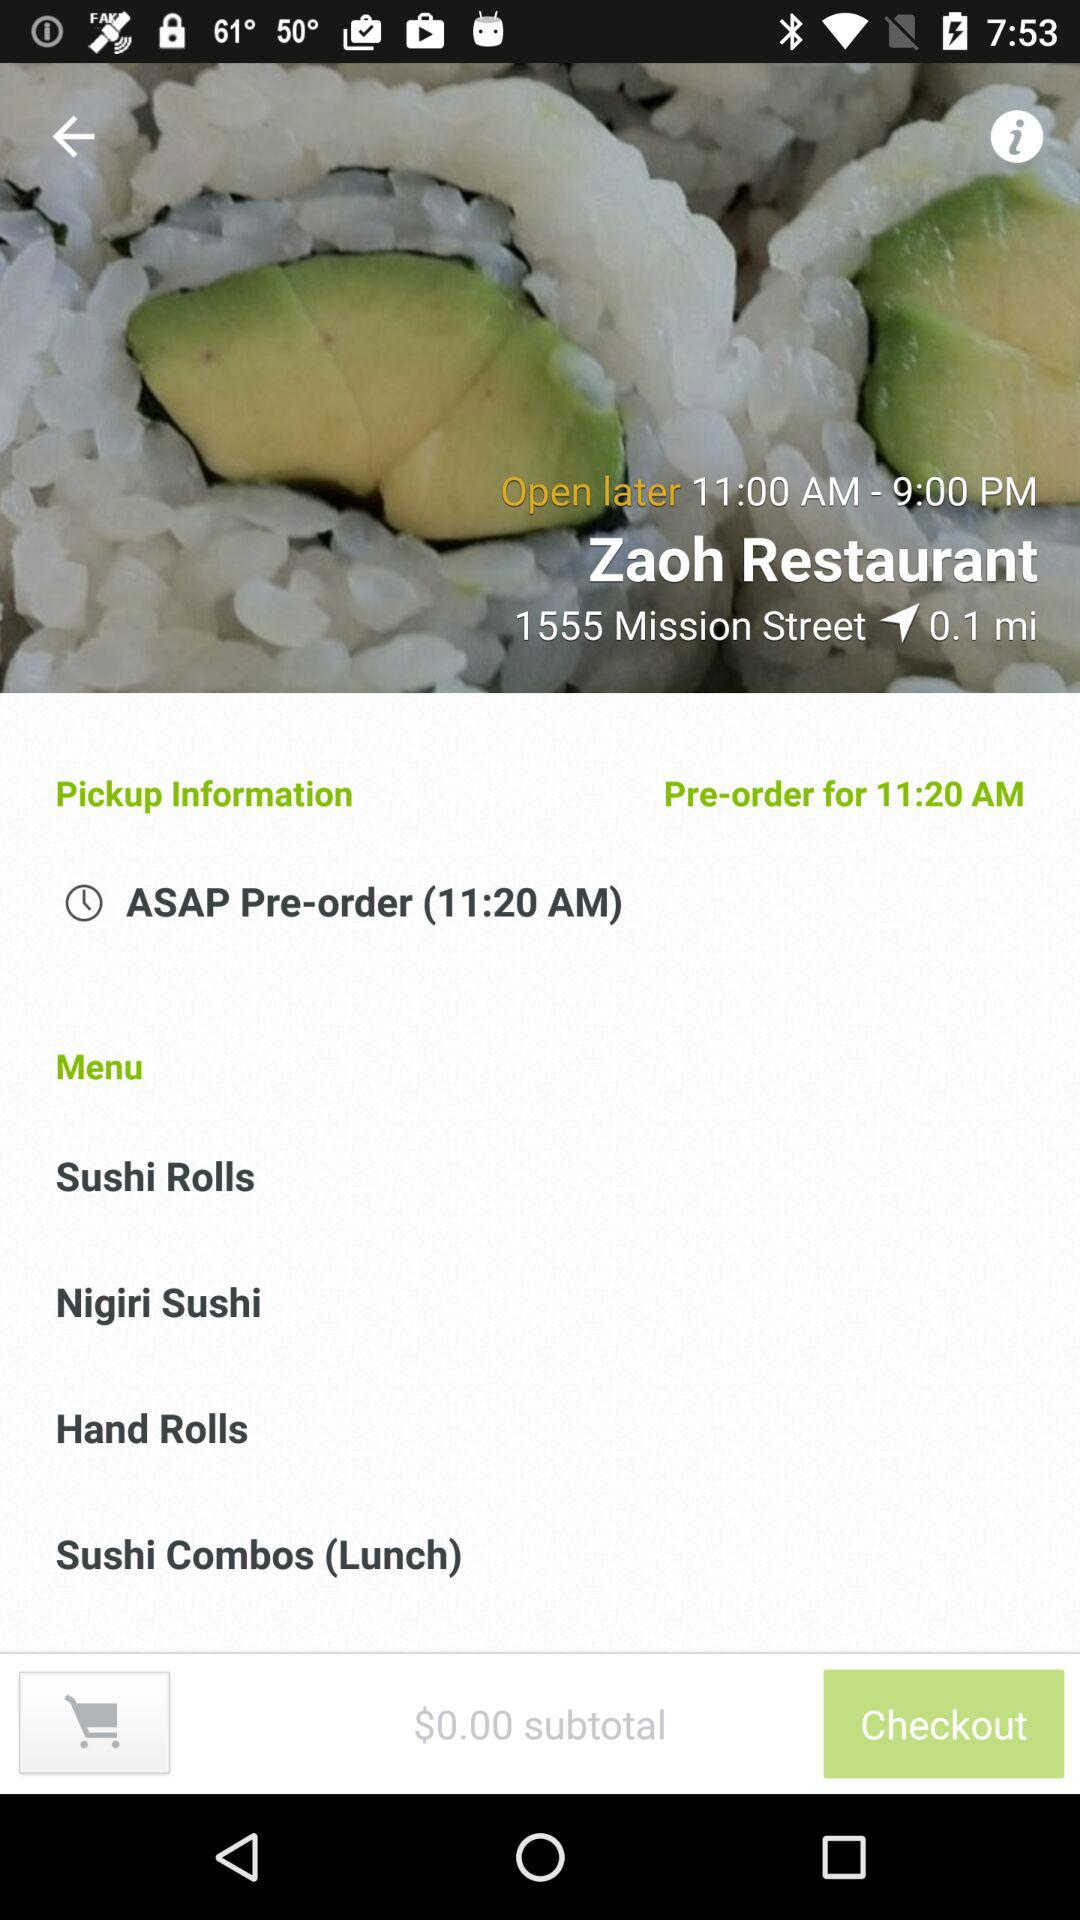What is the location of Zaoh restaurant? The location of Zaoh restaurant is 1555 Mission Street. 